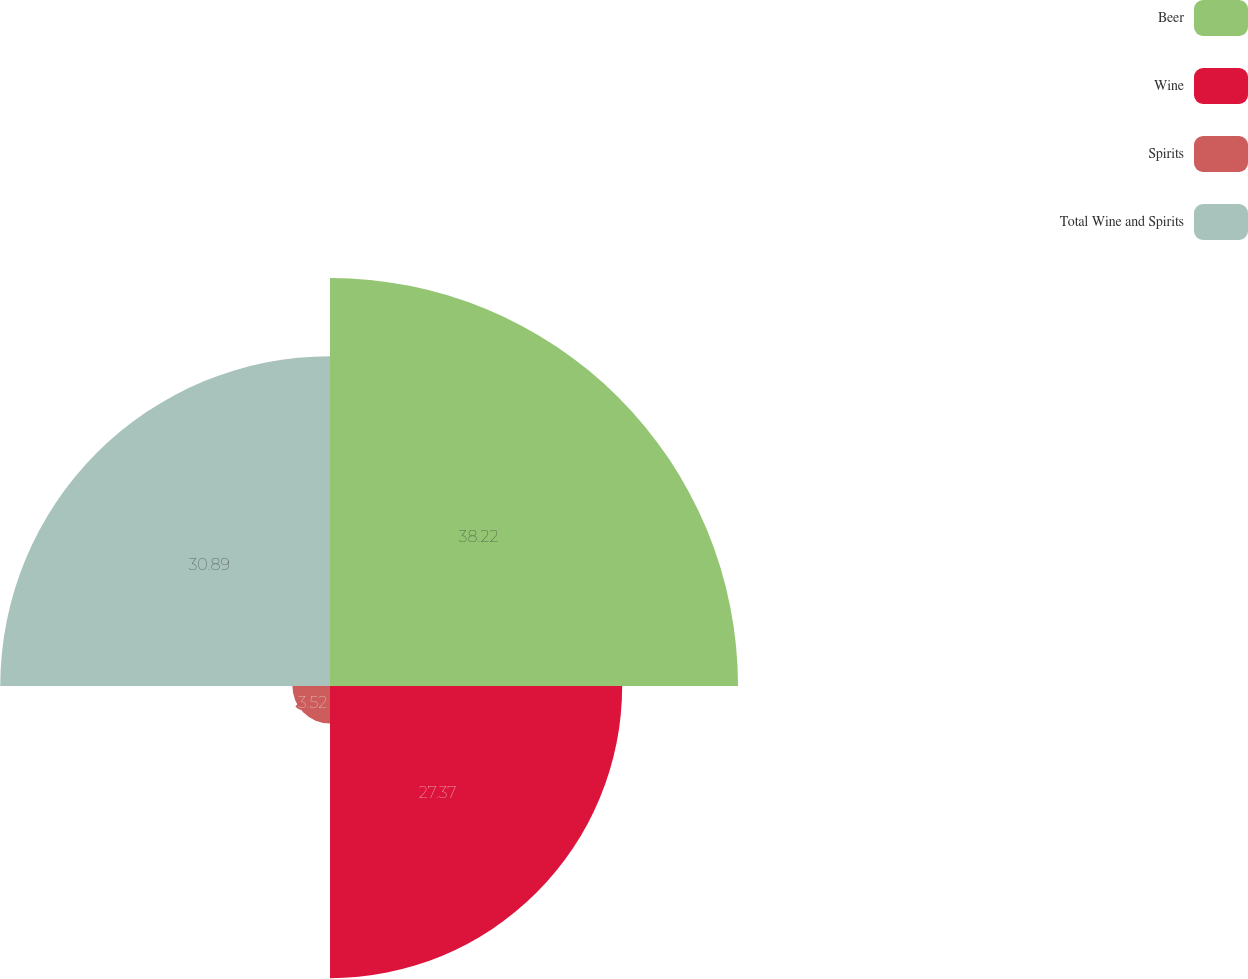Convert chart to OTSL. <chart><loc_0><loc_0><loc_500><loc_500><pie_chart><fcel>Beer<fcel>Wine<fcel>Spirits<fcel>Total Wine and Spirits<nl><fcel>38.22%<fcel>27.37%<fcel>3.52%<fcel>30.89%<nl></chart> 